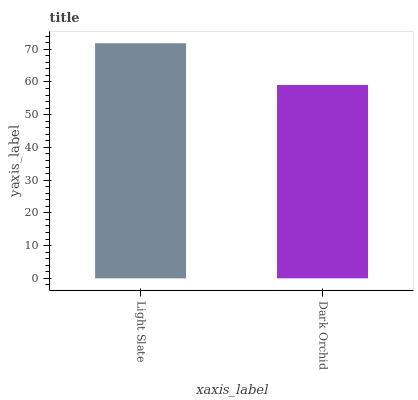Is Dark Orchid the minimum?
Answer yes or no. Yes. Is Light Slate the maximum?
Answer yes or no. Yes. Is Dark Orchid the maximum?
Answer yes or no. No. Is Light Slate greater than Dark Orchid?
Answer yes or no. Yes. Is Dark Orchid less than Light Slate?
Answer yes or no. Yes. Is Dark Orchid greater than Light Slate?
Answer yes or no. No. Is Light Slate less than Dark Orchid?
Answer yes or no. No. Is Light Slate the high median?
Answer yes or no. Yes. Is Dark Orchid the low median?
Answer yes or no. Yes. Is Dark Orchid the high median?
Answer yes or no. No. Is Light Slate the low median?
Answer yes or no. No. 